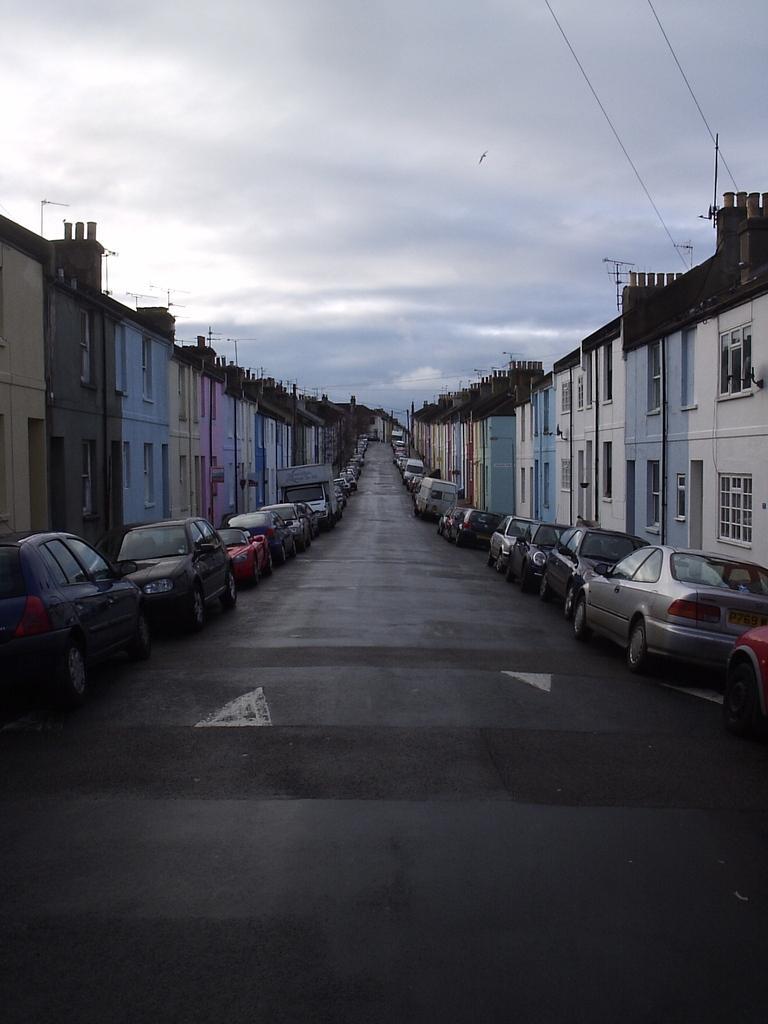How would you summarize this image in a sentence or two? This is an outside view. At the bottom there is a road. On both sides of the road there are many cars and buildings. At the top of the image I can see the sky and clouds. 